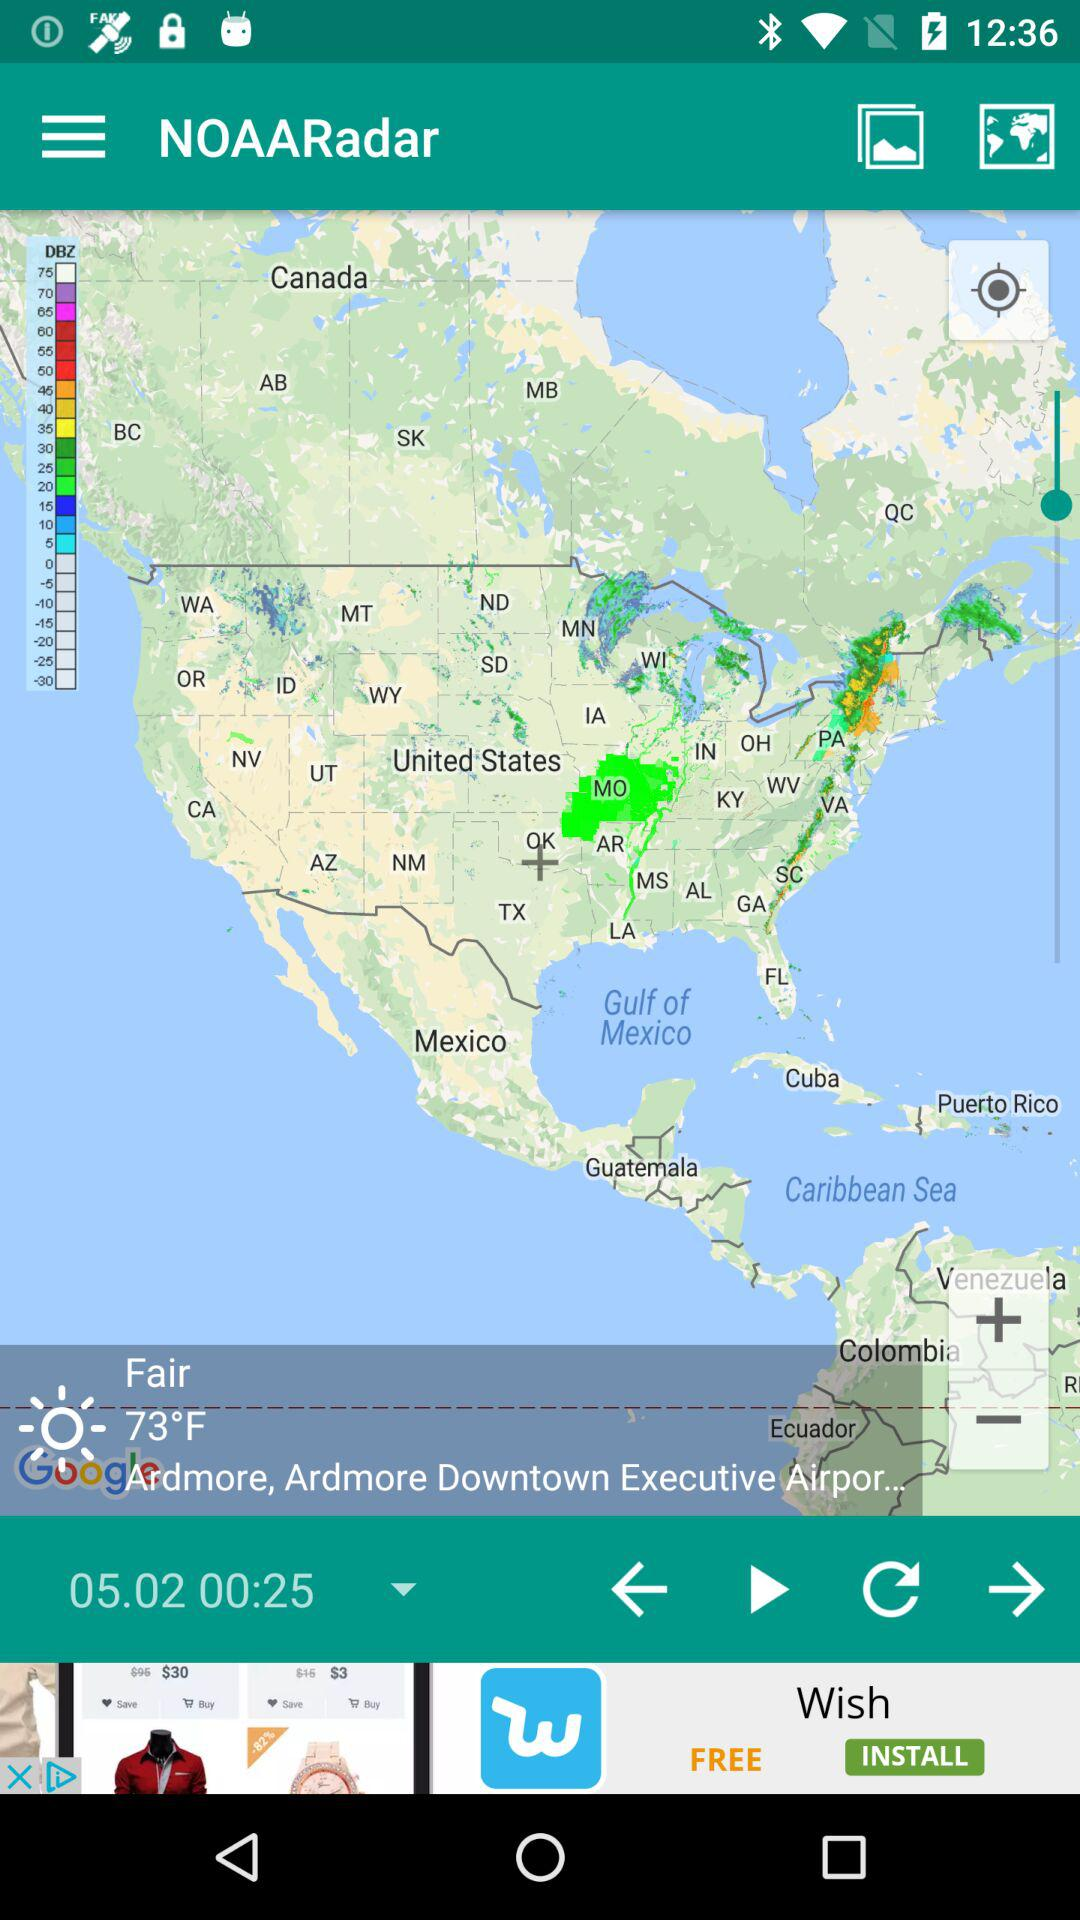What is the name of the application? The name of the application is "NOAARadar". 